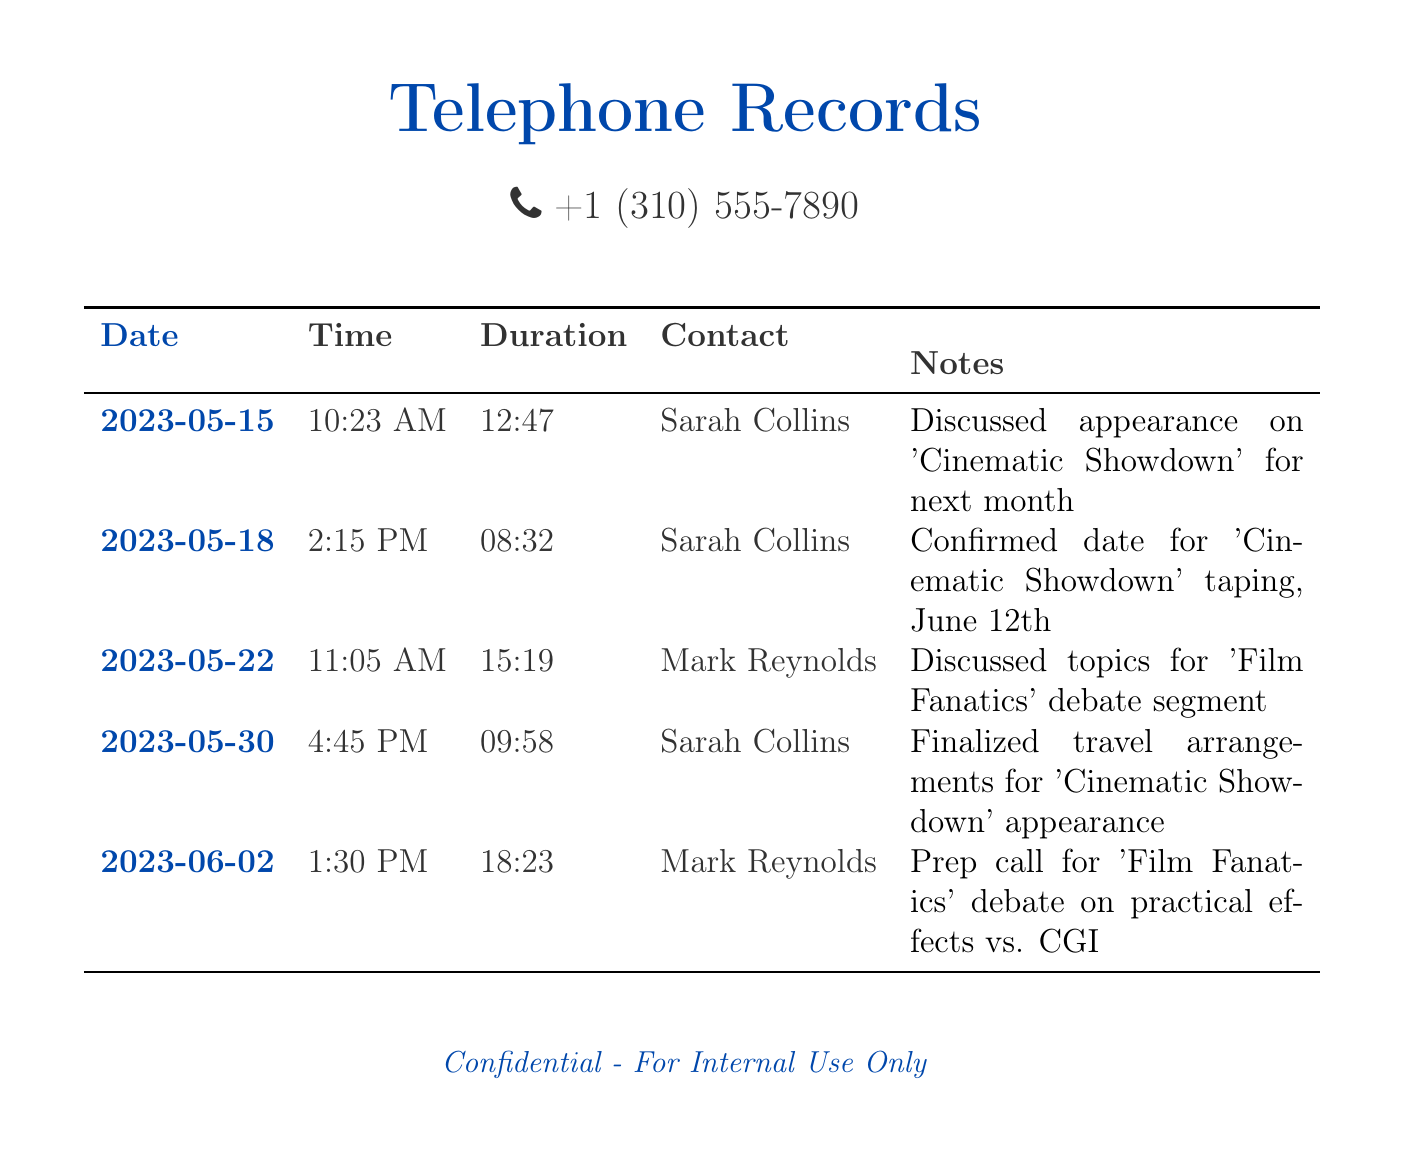What is the date of the first call? The first call listed in the document is dated May 15, 2023.
Answer: May 15, 2023 Who is the producer discussed in the first call? The producer mentioned in the first call is Sarah Collins.
Answer: Sarah Collins What is the duration of the call on May 22? The duration for the May 22 call is 15 minutes and 19 seconds.
Answer: 15:19 What was confirmed during the call on May 18? During the May 18 call, the date for the taping of 'Cinematic Showdown' was confirmed.
Answer: Date for 'Cinematic Showdown' Which show is scheduled for a taping on June 12? The document specifies 'Cinematic Showdown' is scheduled for taping on June 12, 2023.
Answer: 'Cinematic Showdown' How many calls were made to Sarah Collins? There are three calls listed with Sarah Collins in the document.
Answer: Three What was the main topic of the prep call on June 2? The prep call on June 2 focused on the debate regarding practical effects versus CGI.
Answer: Practical effects vs. CGI What time was the call with Mark Reynolds on May 22? The call with Mark Reynolds on May 22 took place at 11:05 AM.
Answer: 11:05 AM 